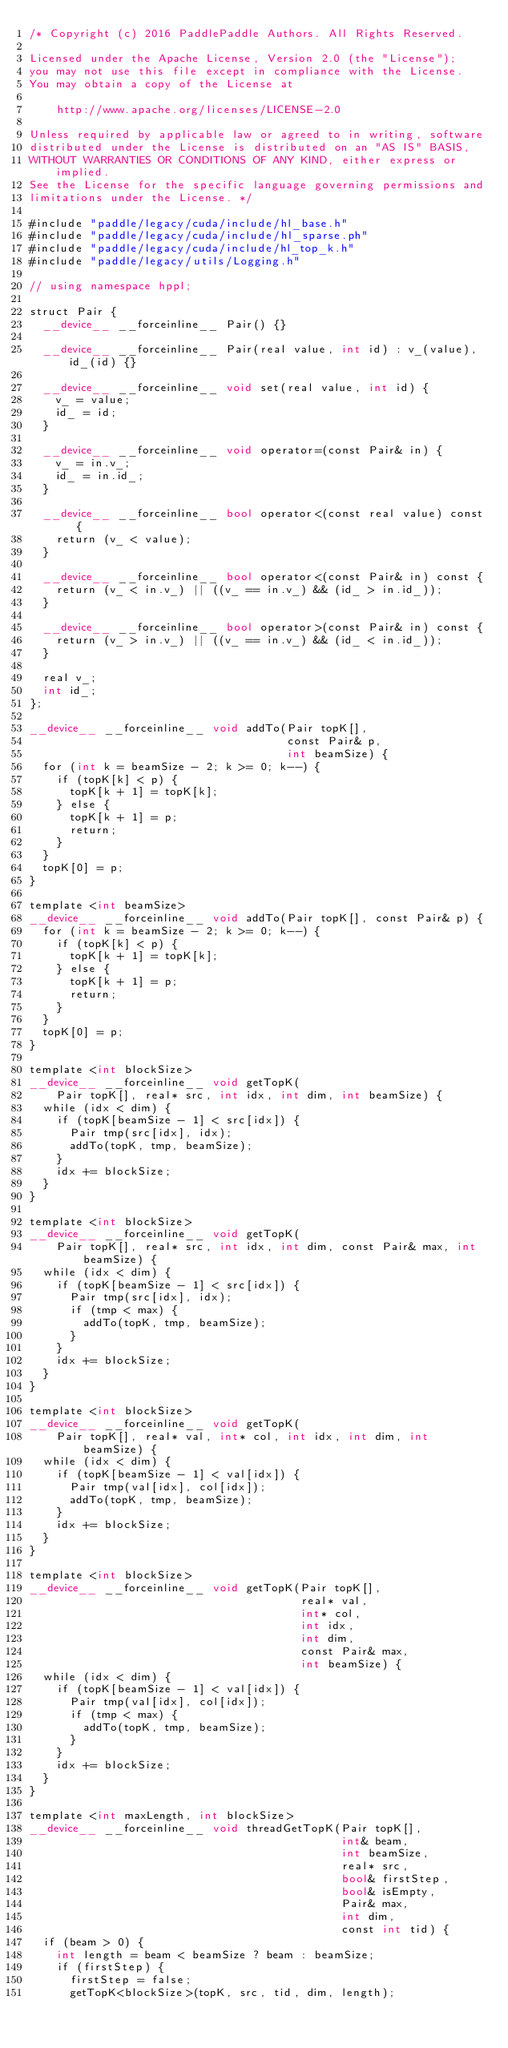<code> <loc_0><loc_0><loc_500><loc_500><_Cuda_>/* Copyright (c) 2016 PaddlePaddle Authors. All Rights Reserved.

Licensed under the Apache License, Version 2.0 (the "License");
you may not use this file except in compliance with the License.
You may obtain a copy of the License at

    http://www.apache.org/licenses/LICENSE-2.0

Unless required by applicable law or agreed to in writing, software
distributed under the License is distributed on an "AS IS" BASIS,
WITHOUT WARRANTIES OR CONDITIONS OF ANY KIND, either express or implied.
See the License for the specific language governing permissions and
limitations under the License. */

#include "paddle/legacy/cuda/include/hl_base.h"
#include "paddle/legacy/cuda/include/hl_sparse.ph"
#include "paddle/legacy/cuda/include/hl_top_k.h"
#include "paddle/legacy/utils/Logging.h"

// using namespace hppl;

struct Pair {
  __device__ __forceinline__ Pair() {}

  __device__ __forceinline__ Pair(real value, int id) : v_(value), id_(id) {}

  __device__ __forceinline__ void set(real value, int id) {
    v_ = value;
    id_ = id;
  }

  __device__ __forceinline__ void operator=(const Pair& in) {
    v_ = in.v_;
    id_ = in.id_;
  }

  __device__ __forceinline__ bool operator<(const real value) const {
    return (v_ < value);
  }

  __device__ __forceinline__ bool operator<(const Pair& in) const {
    return (v_ < in.v_) || ((v_ == in.v_) && (id_ > in.id_));
  }

  __device__ __forceinline__ bool operator>(const Pair& in) const {
    return (v_ > in.v_) || ((v_ == in.v_) && (id_ < in.id_));
  }

  real v_;
  int id_;
};

__device__ __forceinline__ void addTo(Pair topK[],
                                      const Pair& p,
                                      int beamSize) {
  for (int k = beamSize - 2; k >= 0; k--) {
    if (topK[k] < p) {
      topK[k + 1] = topK[k];
    } else {
      topK[k + 1] = p;
      return;
    }
  }
  topK[0] = p;
}

template <int beamSize>
__device__ __forceinline__ void addTo(Pair topK[], const Pair& p) {
  for (int k = beamSize - 2; k >= 0; k--) {
    if (topK[k] < p) {
      topK[k + 1] = topK[k];
    } else {
      topK[k + 1] = p;
      return;
    }
  }
  topK[0] = p;
}

template <int blockSize>
__device__ __forceinline__ void getTopK(
    Pair topK[], real* src, int idx, int dim, int beamSize) {
  while (idx < dim) {
    if (topK[beamSize - 1] < src[idx]) {
      Pair tmp(src[idx], idx);
      addTo(topK, tmp, beamSize);
    }
    idx += blockSize;
  }
}

template <int blockSize>
__device__ __forceinline__ void getTopK(
    Pair topK[], real* src, int idx, int dim, const Pair& max, int beamSize) {
  while (idx < dim) {
    if (topK[beamSize - 1] < src[idx]) {
      Pair tmp(src[idx], idx);
      if (tmp < max) {
        addTo(topK, tmp, beamSize);
      }
    }
    idx += blockSize;
  }
}

template <int blockSize>
__device__ __forceinline__ void getTopK(
    Pair topK[], real* val, int* col, int idx, int dim, int beamSize) {
  while (idx < dim) {
    if (topK[beamSize - 1] < val[idx]) {
      Pair tmp(val[idx], col[idx]);
      addTo(topK, tmp, beamSize);
    }
    idx += blockSize;
  }
}

template <int blockSize>
__device__ __forceinline__ void getTopK(Pair topK[],
                                        real* val,
                                        int* col,
                                        int idx,
                                        int dim,
                                        const Pair& max,
                                        int beamSize) {
  while (idx < dim) {
    if (topK[beamSize - 1] < val[idx]) {
      Pair tmp(val[idx], col[idx]);
      if (tmp < max) {
        addTo(topK, tmp, beamSize);
      }
    }
    idx += blockSize;
  }
}

template <int maxLength, int blockSize>
__device__ __forceinline__ void threadGetTopK(Pair topK[],
                                              int& beam,
                                              int beamSize,
                                              real* src,
                                              bool& firstStep,
                                              bool& isEmpty,
                                              Pair& max,
                                              int dim,
                                              const int tid) {
  if (beam > 0) {
    int length = beam < beamSize ? beam : beamSize;
    if (firstStep) {
      firstStep = false;
      getTopK<blockSize>(topK, src, tid, dim, length);</code> 